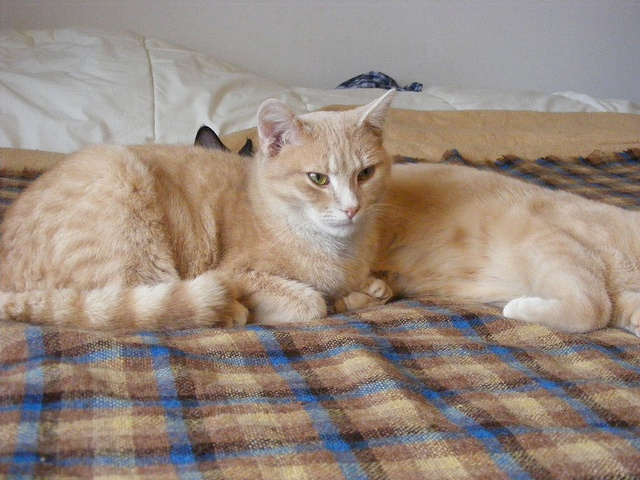Describe the objects in this image and their specific colors. I can see bed in darkgray, gray, and tan tones, cat in gray and tan tones, and cat in gray and tan tones in this image. 